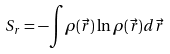Convert formula to latex. <formula><loc_0><loc_0><loc_500><loc_500>S _ { r } = - { \int } { \rho } ( \vec { r } ) \ln { \rho } ( \vec { r } ) d { \vec { r } }</formula> 